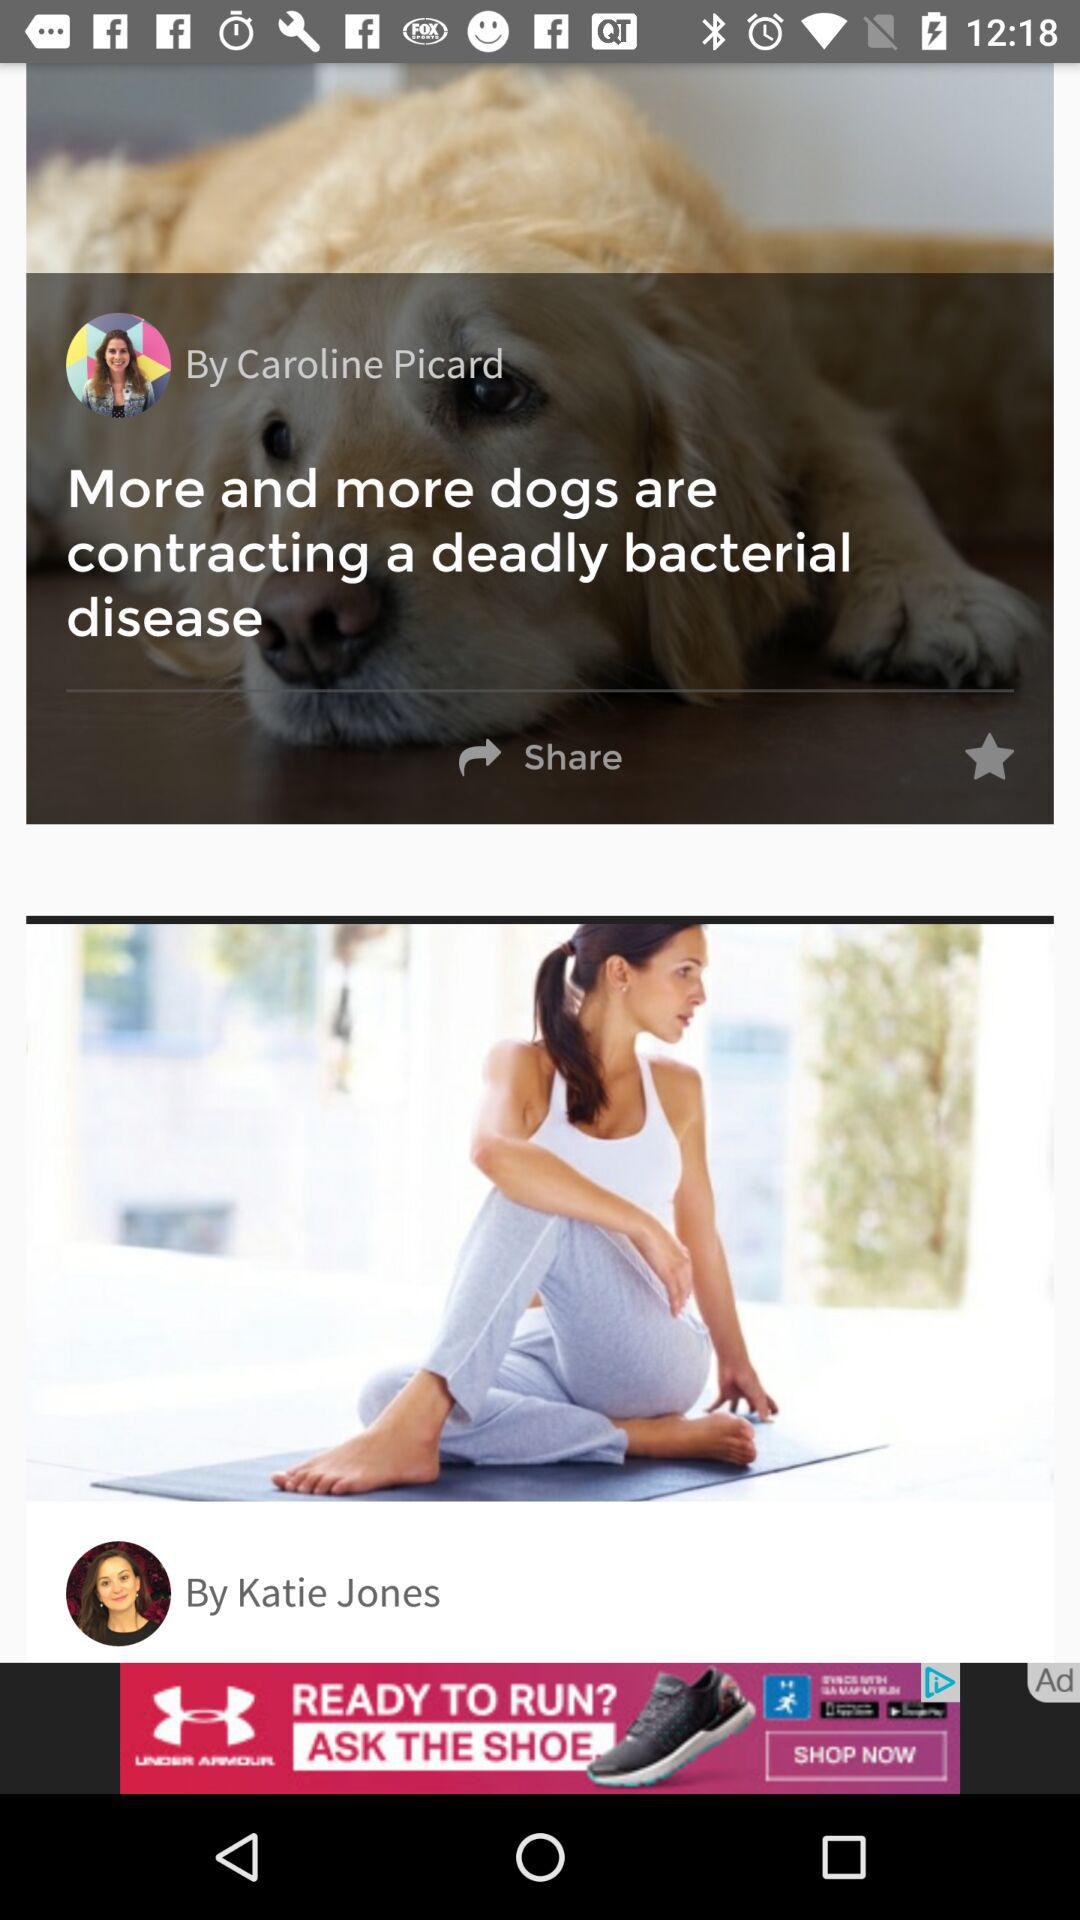When were the posts published?
When the provided information is insufficient, respond with <no answer>. <no answer> 